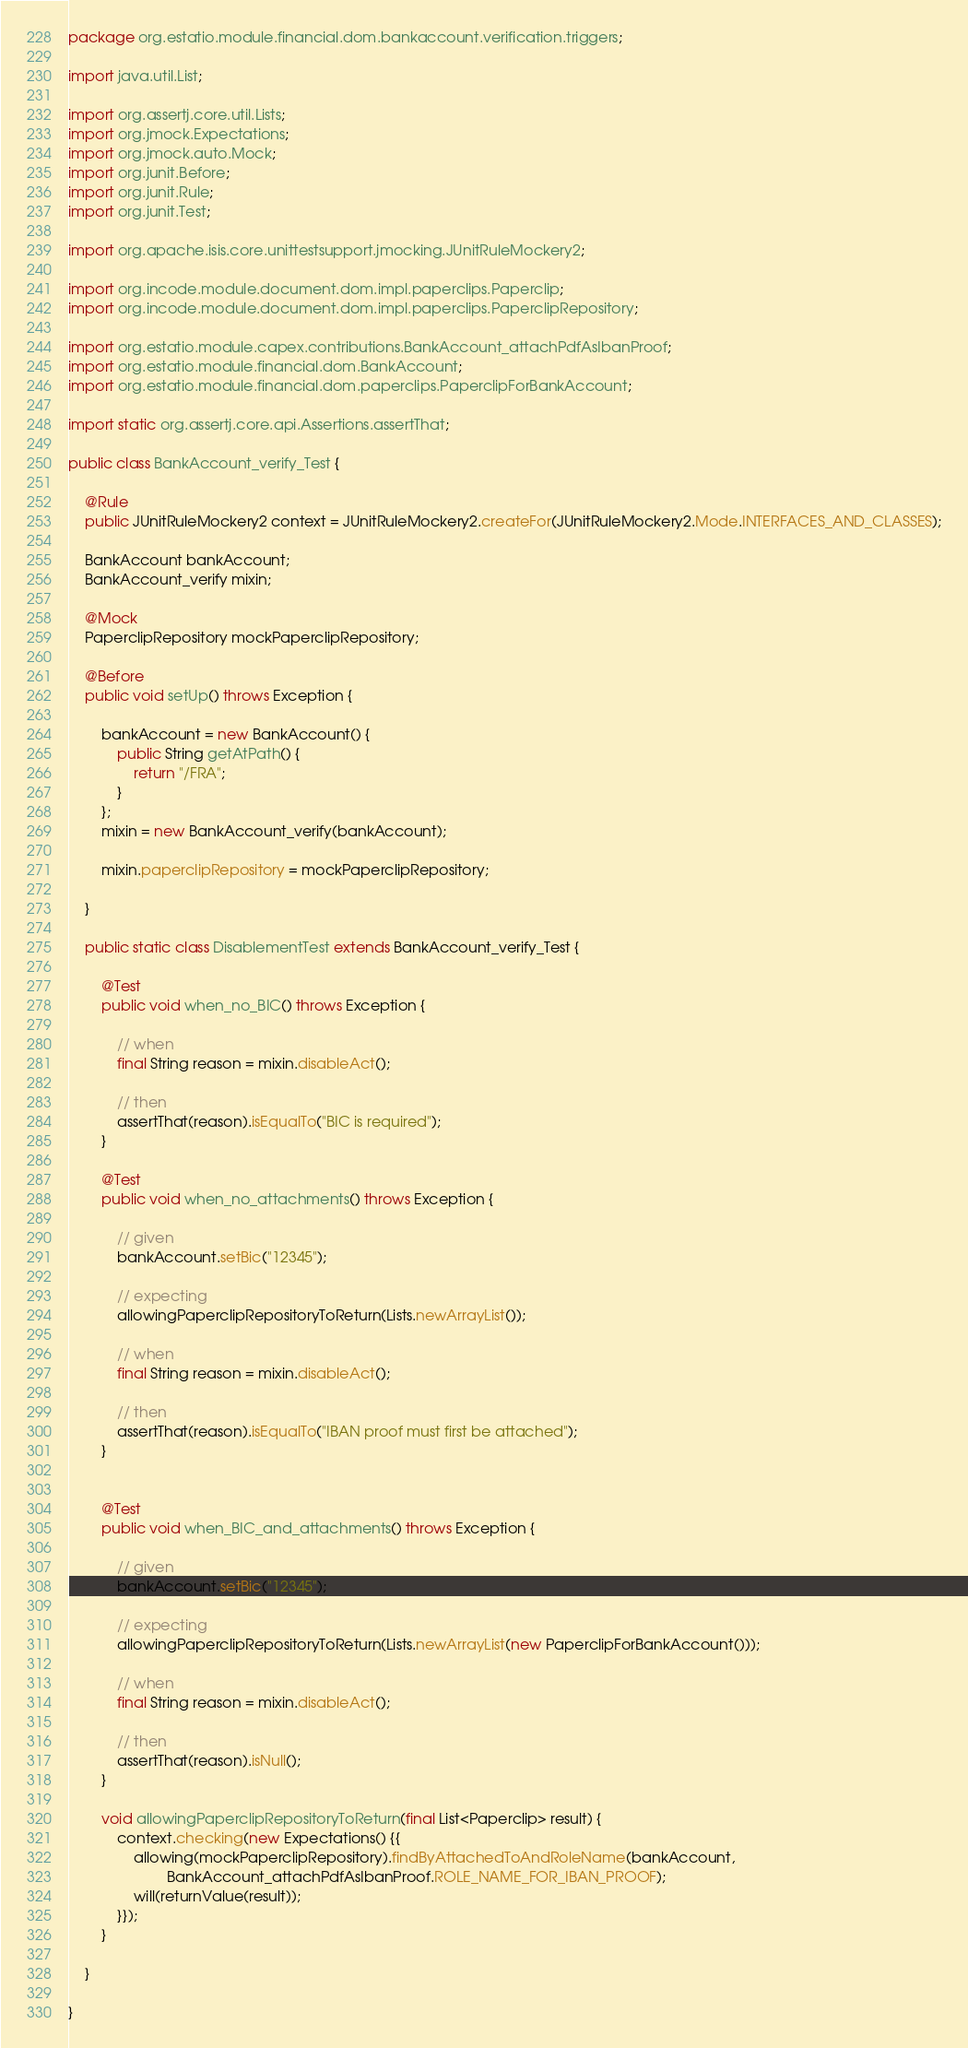<code> <loc_0><loc_0><loc_500><loc_500><_Java_>package org.estatio.module.financial.dom.bankaccount.verification.triggers;

import java.util.List;

import org.assertj.core.util.Lists;
import org.jmock.Expectations;
import org.jmock.auto.Mock;
import org.junit.Before;
import org.junit.Rule;
import org.junit.Test;

import org.apache.isis.core.unittestsupport.jmocking.JUnitRuleMockery2;

import org.incode.module.document.dom.impl.paperclips.Paperclip;
import org.incode.module.document.dom.impl.paperclips.PaperclipRepository;

import org.estatio.module.capex.contributions.BankAccount_attachPdfAsIbanProof;
import org.estatio.module.financial.dom.BankAccount;
import org.estatio.module.financial.dom.paperclips.PaperclipForBankAccount;

import static org.assertj.core.api.Assertions.assertThat;

public class BankAccount_verify_Test {

    @Rule
    public JUnitRuleMockery2 context = JUnitRuleMockery2.createFor(JUnitRuleMockery2.Mode.INTERFACES_AND_CLASSES);

    BankAccount bankAccount;
    BankAccount_verify mixin;

    @Mock
    PaperclipRepository mockPaperclipRepository;

    @Before
    public void setUp() throws Exception {

        bankAccount = new BankAccount() {
            public String getAtPath() {
                return "/FRA";
            }
        };
        mixin = new BankAccount_verify(bankAccount);

        mixin.paperclipRepository = mockPaperclipRepository;

    }

    public static class DisablementTest extends BankAccount_verify_Test {

        @Test
        public void when_no_BIC() throws Exception {

            // when
            final String reason = mixin.disableAct();

            // then
            assertThat(reason).isEqualTo("BIC is required");
        }

        @Test
        public void when_no_attachments() throws Exception {

            // given
            bankAccount.setBic("12345");

            // expecting
            allowingPaperclipRepositoryToReturn(Lists.newArrayList());

            // when
            final String reason = mixin.disableAct();

            // then
            assertThat(reason).isEqualTo("IBAN proof must first be attached");
        }


        @Test
        public void when_BIC_and_attachments() throws Exception {

            // given
            bankAccount.setBic("12345");

            // expecting
            allowingPaperclipRepositoryToReturn(Lists.newArrayList(new PaperclipForBankAccount()));

            // when
            final String reason = mixin.disableAct();

            // then
            assertThat(reason).isNull();
        }

        void allowingPaperclipRepositoryToReturn(final List<Paperclip> result) {
            context.checking(new Expectations() {{
                allowing(mockPaperclipRepository).findByAttachedToAndRoleName(bankAccount,
                        BankAccount_attachPdfAsIbanProof.ROLE_NAME_FOR_IBAN_PROOF);
                will(returnValue(result));
            }});
        }

    }

}</code> 